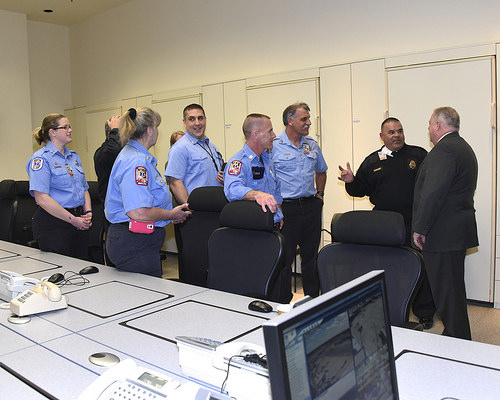<image>
Is there a door behind the table? Yes. From this viewpoint, the door is positioned behind the table, with the table partially or fully occluding the door. 